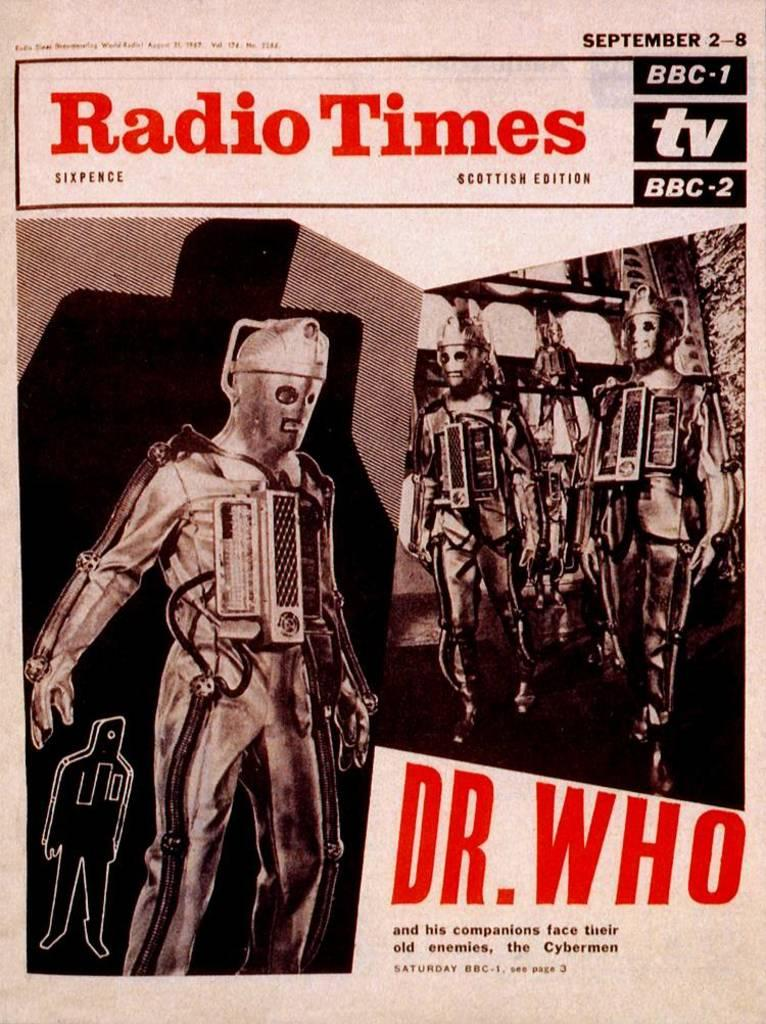<image>
Present a compact description of the photo's key features. An article from the Radio Times that features Dr. Who. 